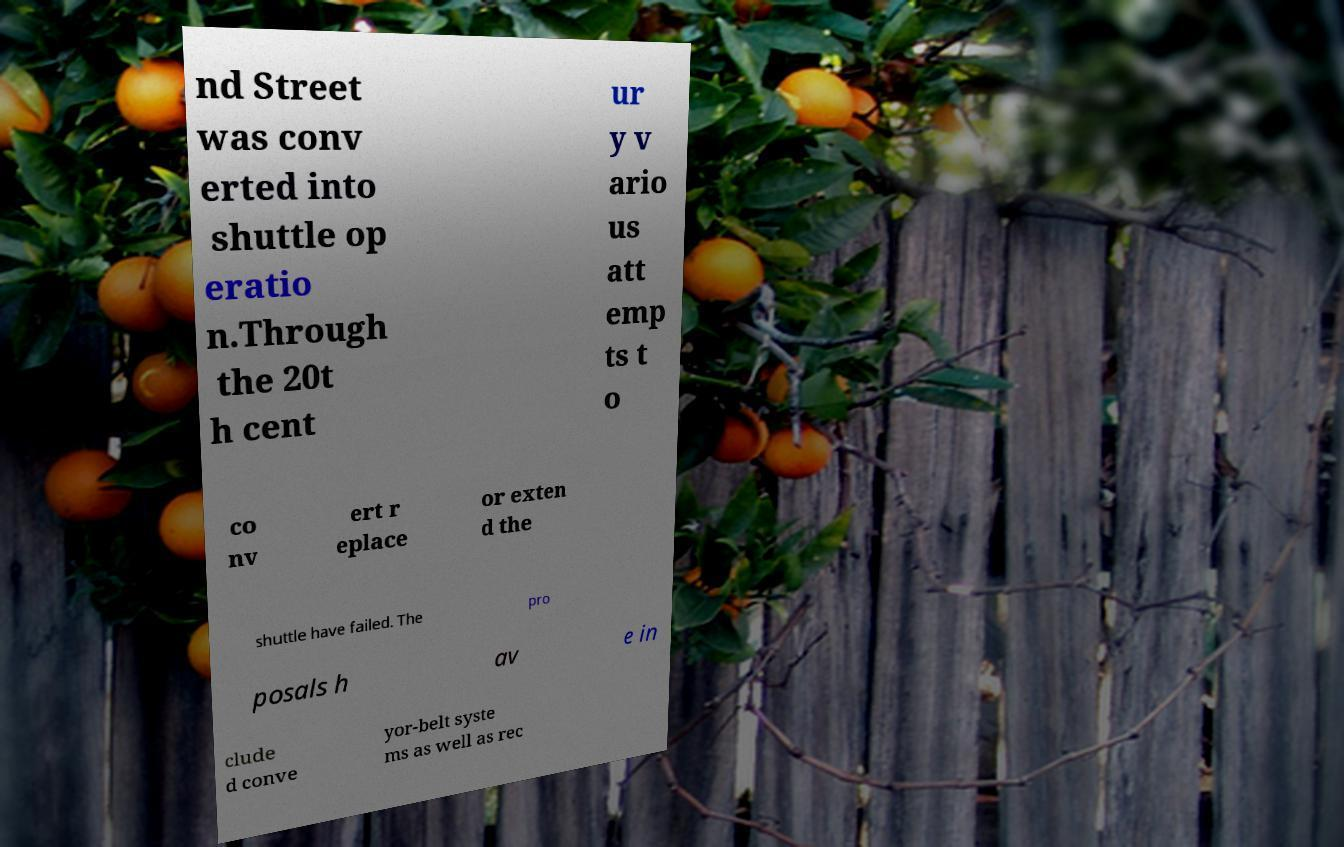What messages or text are displayed in this image? I need them in a readable, typed format. nd Street was conv erted into shuttle op eratio n.Through the 20t h cent ur y v ario us att emp ts t o co nv ert r eplace or exten d the shuttle have failed. The pro posals h av e in clude d conve yor-belt syste ms as well as rec 